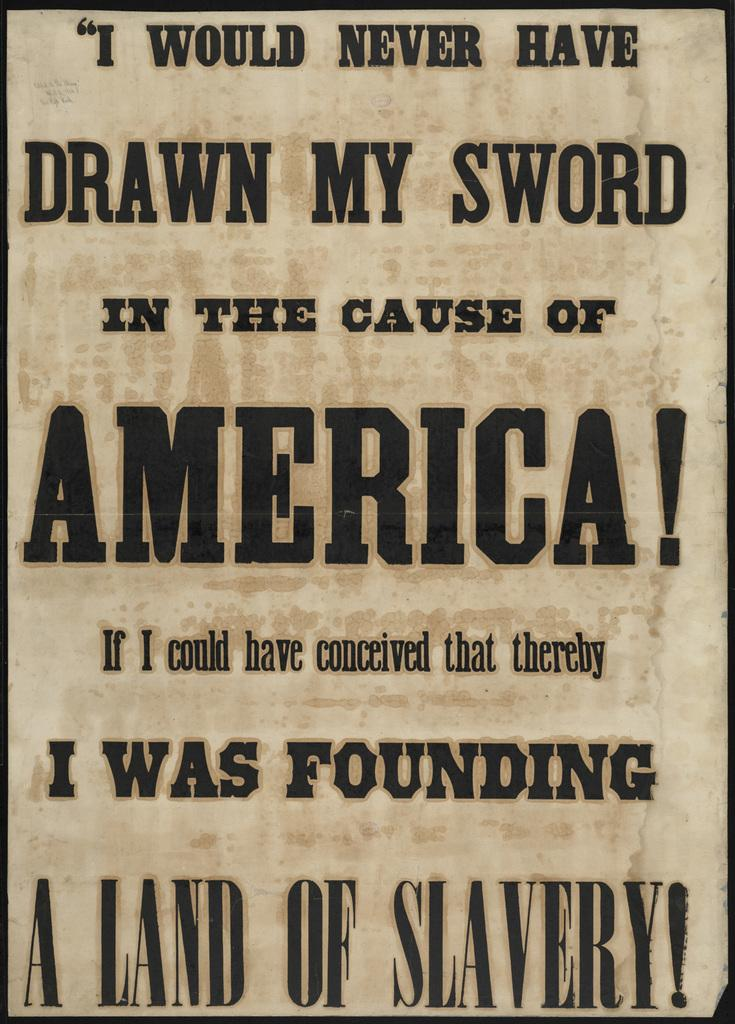Provide a one-sentence caption for the provided image. The sign does not defend America and it was created on a land of slaves. 